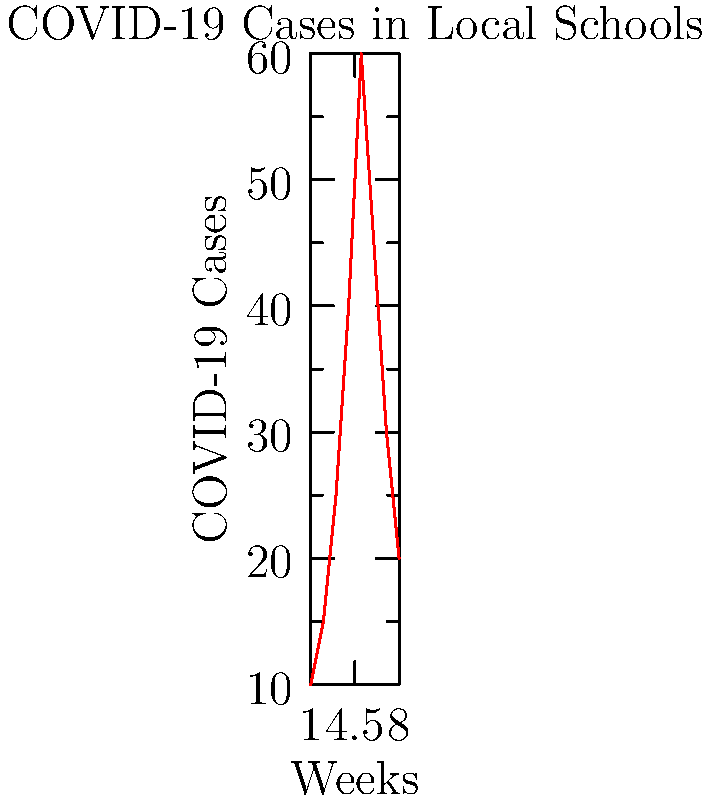Based on the line graph showing COVID-19 case trends in local schools over time, at which week did the number of cases peak, and what policy decision might be appropriate in response to this trend? To answer this question, we need to analyze the graph and consider its implications for policy decisions:

1. Examine the graph: The x-axis represents weeks, and the y-axis represents the number of COVID-19 cases.

2. Identify the peak: The line reaches its highest point at week 5, indicating this is when cases peaked.

3. Observe the trend: 
   - Weeks 1-5: Cases increase steadily
   - Weeks 5-8: Cases decrease

4. Policy implications:
   - The peak at week 5 suggests that any preventive measures implemented were most needed at this time.
   - The subsequent decline indicates that these measures may have been effective.

5. Appropriate policy decision:
   - Maintain current preventive measures for a short period to ensure the downward trend continues.
   - Plan for a phased reopening of schools if the downward trend persists for 2-3 more weeks.
   - Implement a monitoring system to quickly identify any new outbreaks.

6. Conclusion: The appropriate policy decision would be to maintain current restrictions for a short period, then begin a careful, phased reopening if the downward trend continues, while maintaining vigilant monitoring.
Answer: Week 5; maintain current restrictions briefly, then initiate phased reopening if downward trend continues, with ongoing monitoring. 